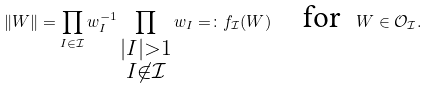<formula> <loc_0><loc_0><loc_500><loc_500>\| W \| = \prod _ { I \in \mathcal { I } } w _ { I } ^ { - 1 } \prod _ { \substack { | I | > 1 \\ I \not \in \mathcal { I } } } w _ { I } = \colon f _ { \mathcal { I } } ( W ) \quad \text {for } \ W \in \mathcal { O } _ { \mathcal { I } } .</formula> 